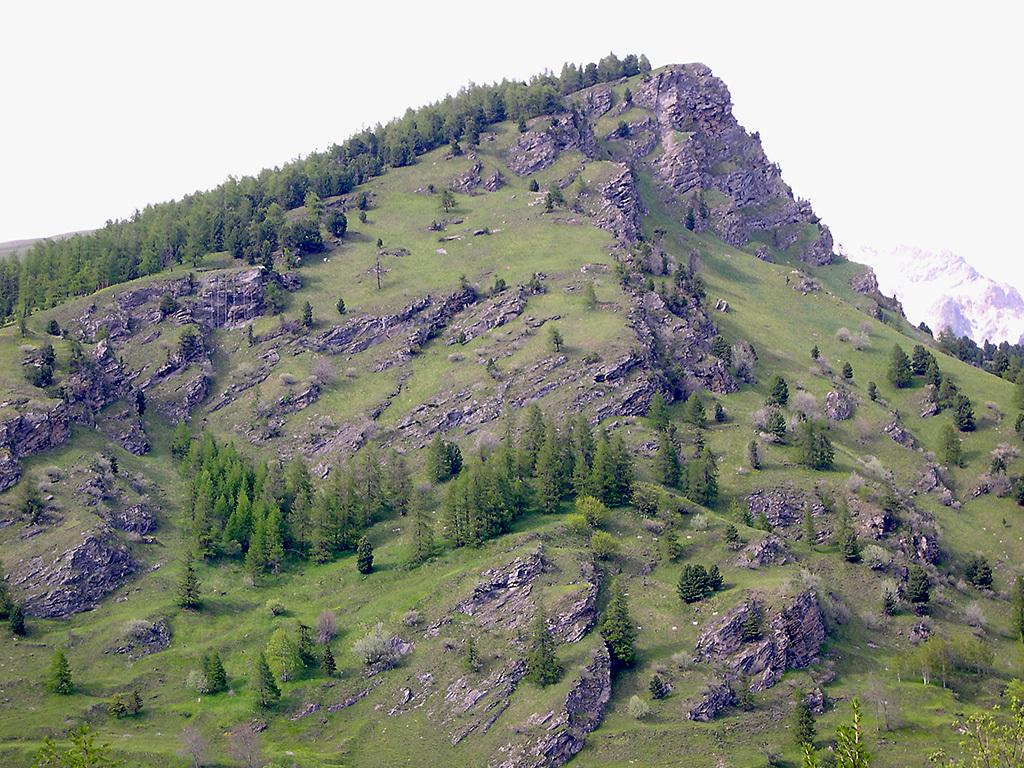What type of vegetation can be seen on the hill in the image? There are trees, plants, and grass on the hill in the image. What is the condition of the sky in the image? The sky is clear in the image. What type of crime is being committed on the hill in the image? There is no indication of any crime being committed in the image; it features a hill with vegetation and a clear sky. What type of rhythm can be heard coming from the zoo in the image? There is no zoo present in the image, so no rhythm can be heard coming from it. 